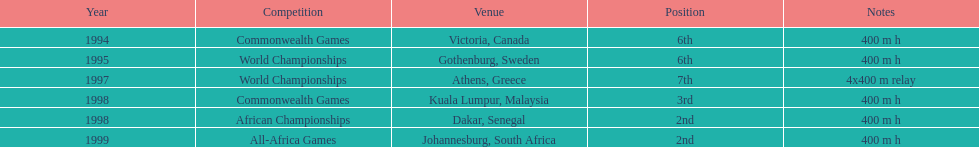During the 1997 world championships, how lengthy was the relay race that featured ken harden? 4x400 m relay. 